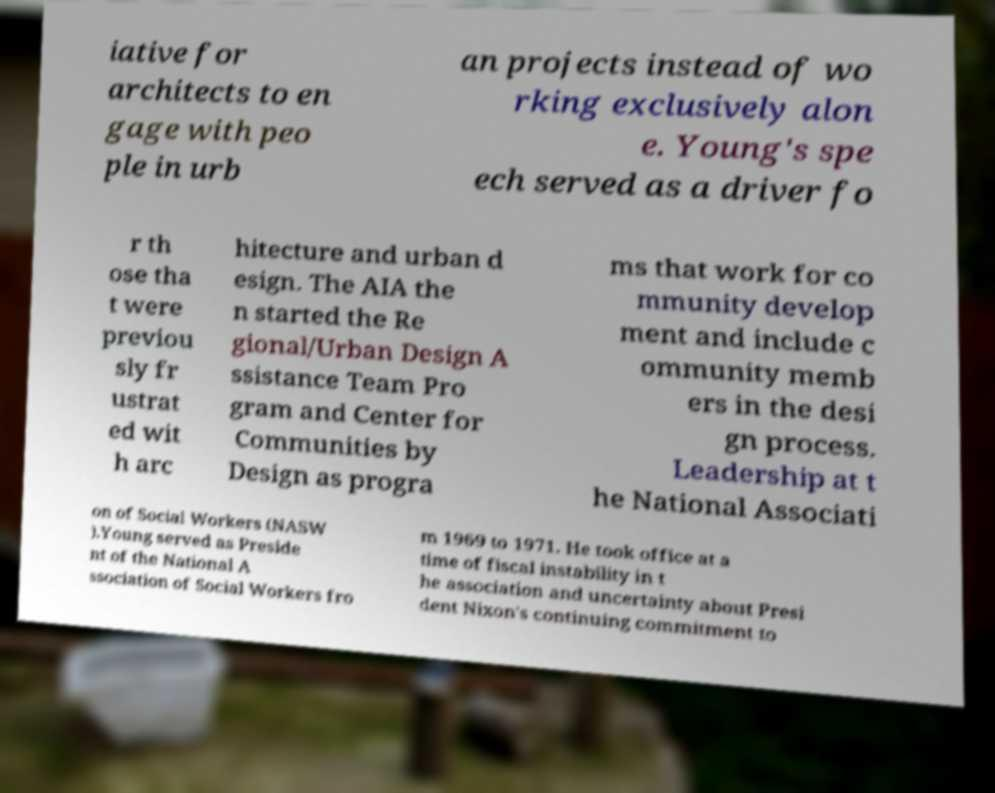Can you read and provide the text displayed in the image?This photo seems to have some interesting text. Can you extract and type it out for me? iative for architects to en gage with peo ple in urb an projects instead of wo rking exclusively alon e. Young's spe ech served as a driver fo r th ose tha t were previou sly fr ustrat ed wit h arc hitecture and urban d esign. The AIA the n started the Re gional/Urban Design A ssistance Team Pro gram and Center for Communities by Design as progra ms that work for co mmunity develop ment and include c ommunity memb ers in the desi gn process. Leadership at t he National Associati on of Social Workers (NASW ).Young served as Preside nt of the National A ssociation of Social Workers fro m 1969 to 1971. He took office at a time of fiscal instability in t he association and uncertainty about Presi dent Nixon's continuing commitment to 